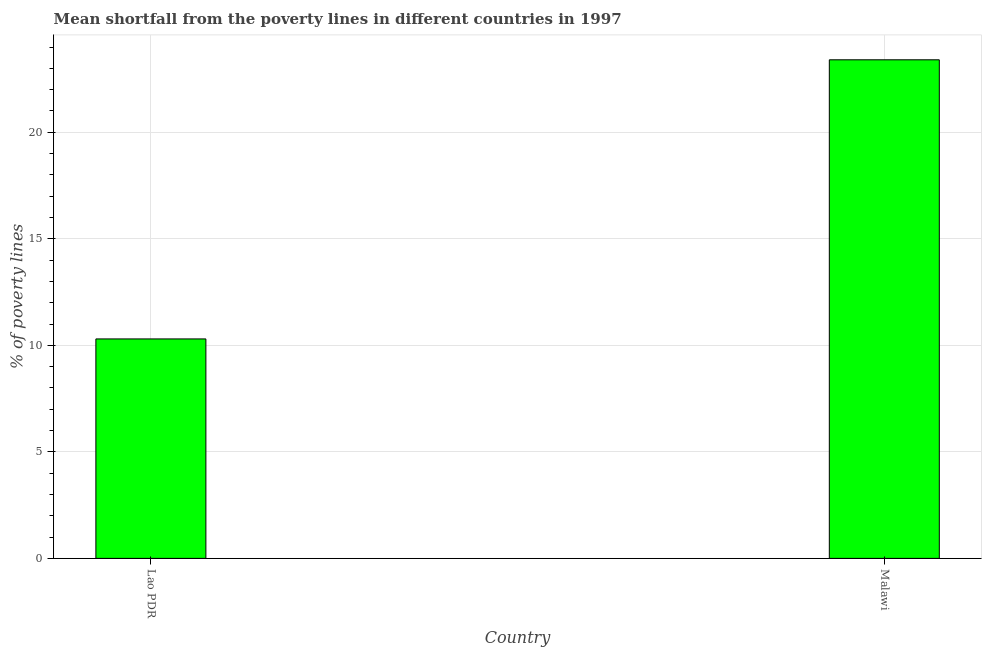What is the title of the graph?
Your answer should be compact. Mean shortfall from the poverty lines in different countries in 1997. What is the label or title of the X-axis?
Your answer should be very brief. Country. What is the label or title of the Y-axis?
Offer a very short reply. % of poverty lines. Across all countries, what is the maximum poverty gap at national poverty lines?
Your answer should be compact. 23.4. In which country was the poverty gap at national poverty lines maximum?
Your answer should be very brief. Malawi. In which country was the poverty gap at national poverty lines minimum?
Your answer should be very brief. Lao PDR. What is the sum of the poverty gap at national poverty lines?
Provide a succinct answer. 33.7. What is the average poverty gap at national poverty lines per country?
Provide a short and direct response. 16.85. What is the median poverty gap at national poverty lines?
Offer a very short reply. 16.85. What is the ratio of the poverty gap at national poverty lines in Lao PDR to that in Malawi?
Keep it short and to the point. 0.44. Is the poverty gap at national poverty lines in Lao PDR less than that in Malawi?
Provide a short and direct response. Yes. How many countries are there in the graph?
Your answer should be compact. 2. Are the values on the major ticks of Y-axis written in scientific E-notation?
Your response must be concise. No. What is the % of poverty lines in Malawi?
Provide a short and direct response. 23.4. What is the difference between the % of poverty lines in Lao PDR and Malawi?
Your answer should be very brief. -13.1. What is the ratio of the % of poverty lines in Lao PDR to that in Malawi?
Your response must be concise. 0.44. 